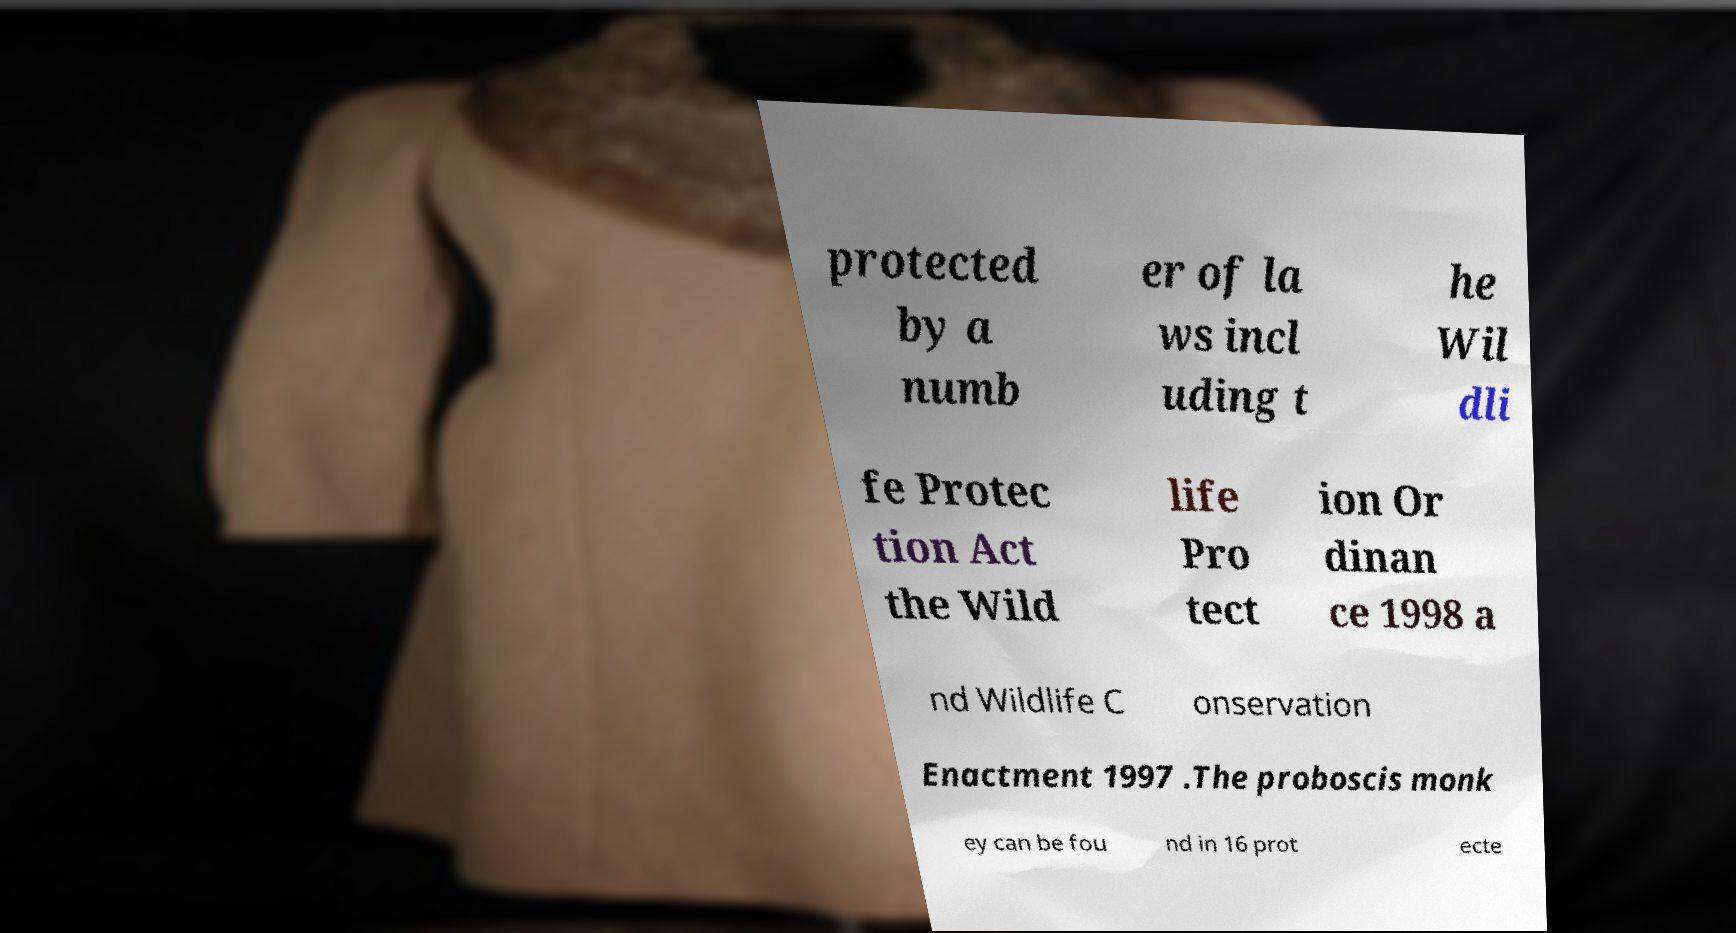Can you read and provide the text displayed in the image?This photo seems to have some interesting text. Can you extract and type it out for me? protected by a numb er of la ws incl uding t he Wil dli fe Protec tion Act the Wild life Pro tect ion Or dinan ce 1998 a nd Wildlife C onservation Enactment 1997 .The proboscis monk ey can be fou nd in 16 prot ecte 